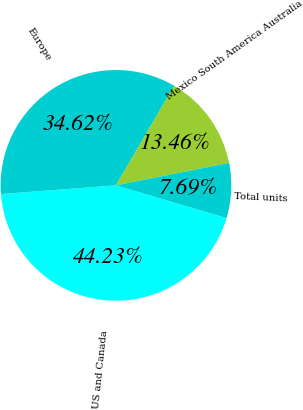Convert chart. <chart><loc_0><loc_0><loc_500><loc_500><pie_chart><fcel>US and Canada<fcel>Europe<fcel>Mexico South America Australia<fcel>Total units<nl><fcel>44.23%<fcel>34.62%<fcel>13.46%<fcel>7.69%<nl></chart> 